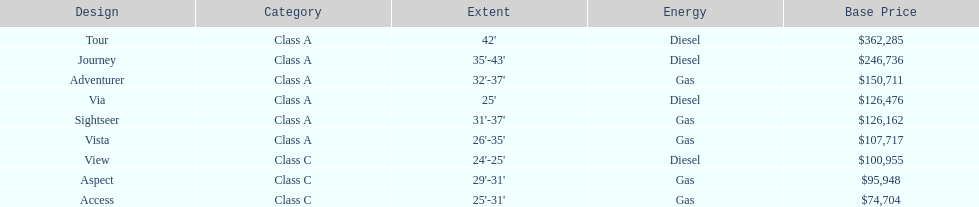Which model is a diesel, the tour or the aspect? Tour. 